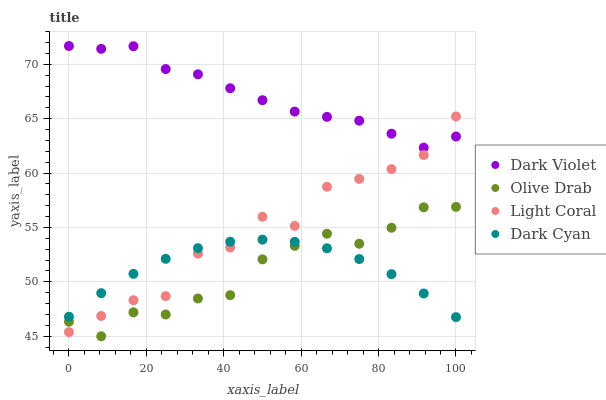Does Olive Drab have the minimum area under the curve?
Answer yes or no. Yes. Does Dark Violet have the maximum area under the curve?
Answer yes or no. Yes. Does Dark Cyan have the minimum area under the curve?
Answer yes or no. No. Does Dark Cyan have the maximum area under the curve?
Answer yes or no. No. Is Dark Cyan the smoothest?
Answer yes or no. Yes. Is Light Coral the roughest?
Answer yes or no. Yes. Is Olive Drab the smoothest?
Answer yes or no. No. Is Olive Drab the roughest?
Answer yes or no. No. Does Olive Drab have the lowest value?
Answer yes or no. Yes. Does Dark Cyan have the lowest value?
Answer yes or no. No. Does Dark Violet have the highest value?
Answer yes or no. Yes. Does Olive Drab have the highest value?
Answer yes or no. No. Is Dark Cyan less than Dark Violet?
Answer yes or no. Yes. Is Dark Violet greater than Dark Cyan?
Answer yes or no. Yes. Does Light Coral intersect Dark Violet?
Answer yes or no. Yes. Is Light Coral less than Dark Violet?
Answer yes or no. No. Is Light Coral greater than Dark Violet?
Answer yes or no. No. Does Dark Cyan intersect Dark Violet?
Answer yes or no. No. 